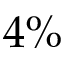Convert formula to latex. <formula><loc_0><loc_0><loc_500><loc_500>4 \%</formula> 